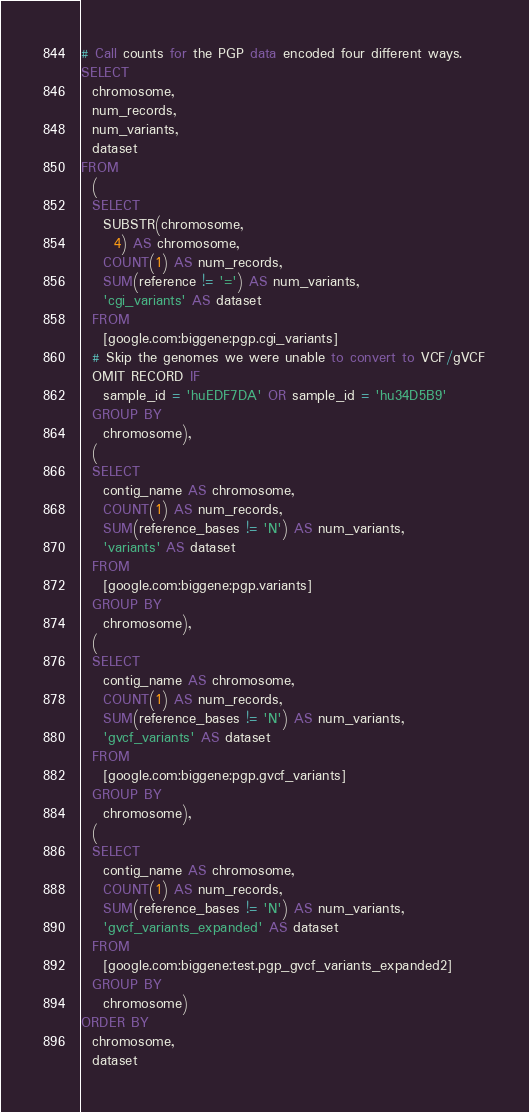Convert code to text. <code><loc_0><loc_0><loc_500><loc_500><_SQL_># Call counts for the PGP data encoded four different ways.
SELECT
  chromosome,
  num_records,
  num_variants,
  dataset
FROM
  (
  SELECT
    SUBSTR(chromosome,
      4) AS chromosome,
    COUNT(1) AS num_records,
    SUM(reference != '=') AS num_variants,
    'cgi_variants' AS dataset
  FROM
    [google.com:biggene:pgp.cgi_variants]
  # Skip the genomes we were unable to convert to VCF/gVCF
  OMIT RECORD IF 
    sample_id = 'huEDF7DA' OR sample_id = 'hu34D5B9'
  GROUP BY
    chromosome),
  (
  SELECT
    contig_name AS chromosome,
    COUNT(1) AS num_records,
    SUM(reference_bases != 'N') AS num_variants,
    'variants' AS dataset
  FROM
    [google.com:biggene:pgp.variants]
  GROUP BY
    chromosome),
  (
  SELECT
    contig_name AS chromosome,
    COUNT(1) AS num_records,
    SUM(reference_bases != 'N') AS num_variants,
    'gvcf_variants' AS dataset
  FROM
    [google.com:biggene:pgp.gvcf_variants]
  GROUP BY
    chromosome),
  (
  SELECT
    contig_name AS chromosome,
    COUNT(1) AS num_records,
    SUM(reference_bases != 'N') AS num_variants,
    'gvcf_variants_expanded' AS dataset
  FROM
    [google.com:biggene:test.pgp_gvcf_variants_expanded2]
  GROUP BY
    chromosome)
ORDER BY
  chromosome,
  dataset
</code> 